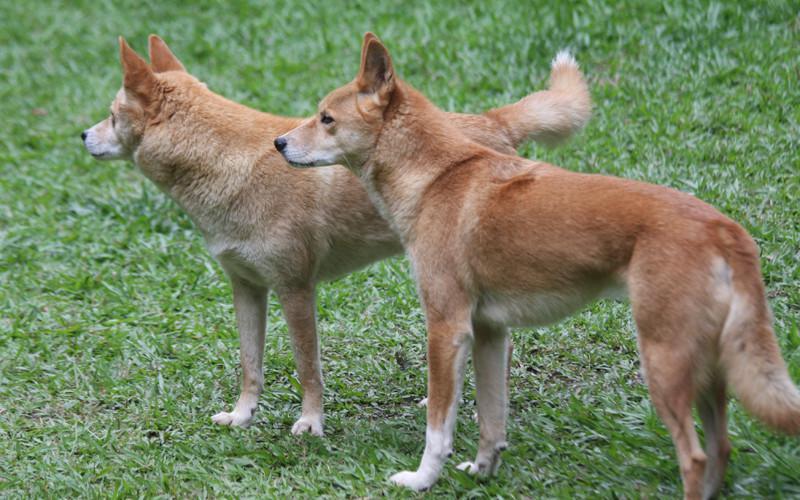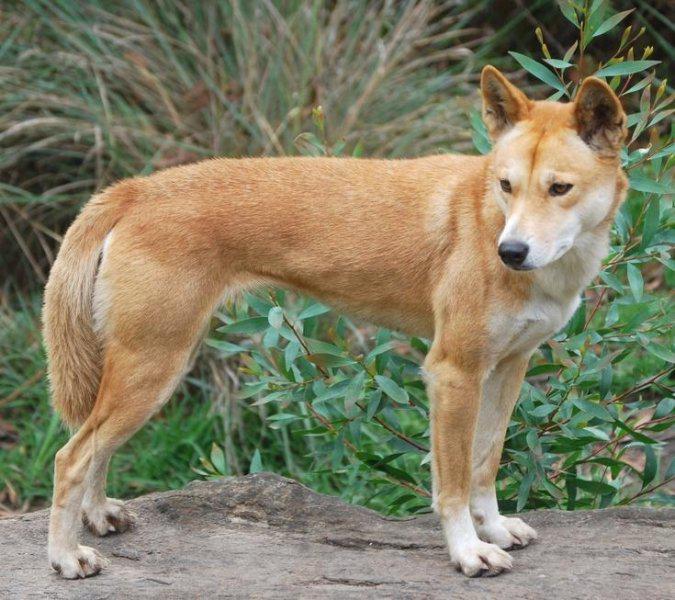The first image is the image on the left, the second image is the image on the right. Evaluate the accuracy of this statement regarding the images: "In at least one image, there are no less than two yellow and white canines standing.". Is it true? Answer yes or no. Yes. 